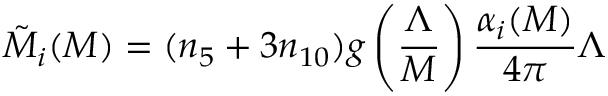<formula> <loc_0><loc_0><loc_500><loc_500>\tilde { M } _ { i } ( M ) = ( n _ { 5 } + 3 n _ { 1 0 } ) g \left ( { \frac { \Lambda } { M } } \right ) { \frac { \alpha _ { i } ( M ) } { 4 \pi } } \Lambda</formula> 